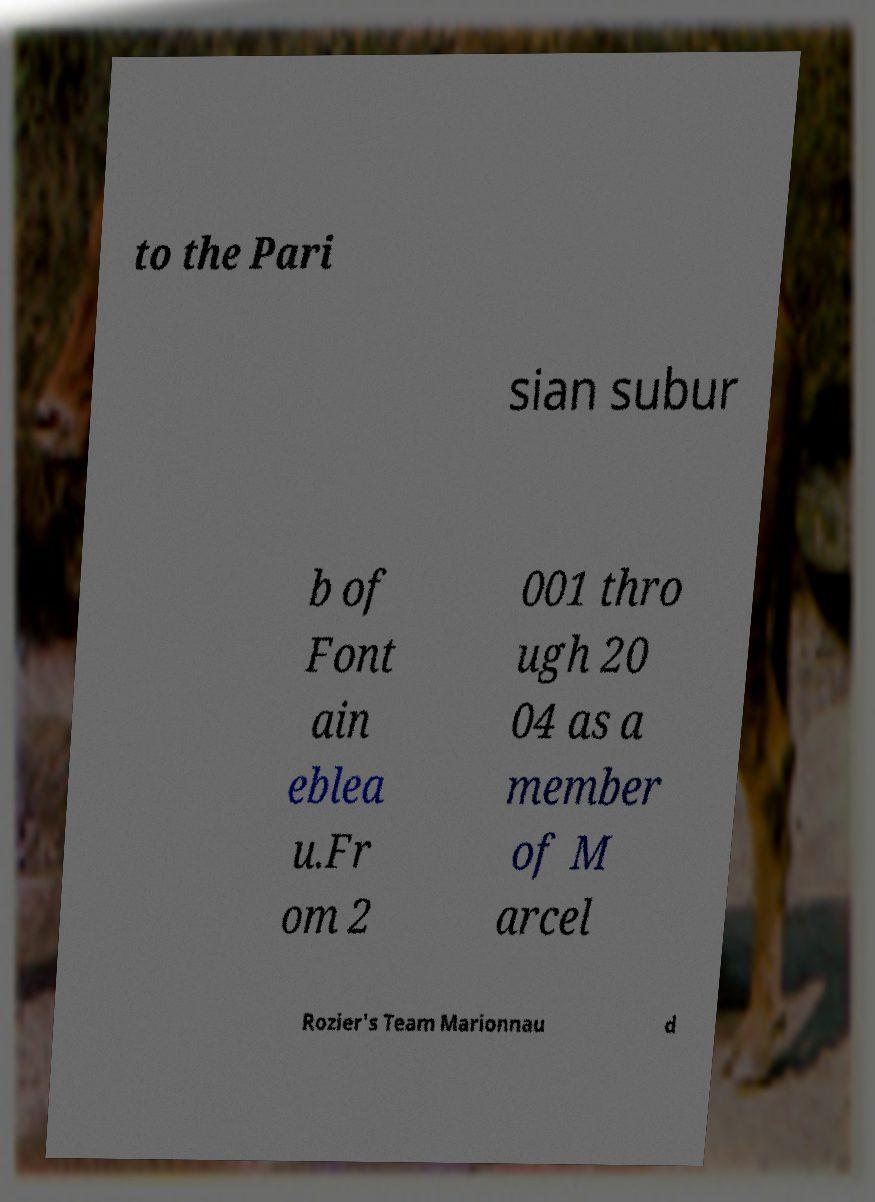Please identify and transcribe the text found in this image. to the Pari sian subur b of Font ain eblea u.Fr om 2 001 thro ugh 20 04 as a member of M arcel Rozier's Team Marionnau d 